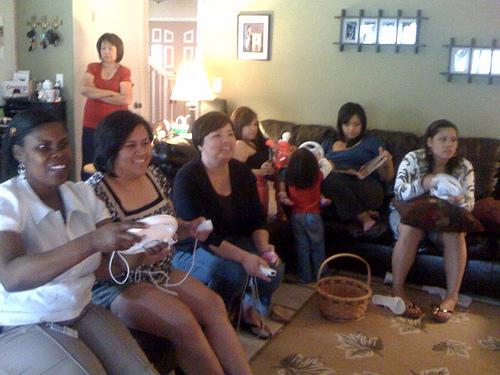Is this a family gathering?
Concise answer only. Yes. How many pictures on wall?
Give a very brief answer. 8. What color is the photo?
Concise answer only. Colored. What are these people playing?
Write a very short answer. Wii. What's in the basket?
Answer briefly. Nothing. What is the team name?
Keep it brief. None. Are they inside?
Quick response, please. Yes. 